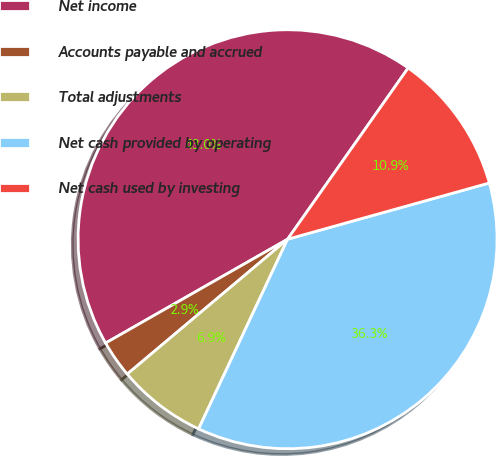Convert chart. <chart><loc_0><loc_0><loc_500><loc_500><pie_chart><fcel>Net income<fcel>Accounts payable and accrued<fcel>Total adjustments<fcel>Net cash provided by operating<fcel>Net cash used by investing<nl><fcel>43.02%<fcel>2.88%<fcel>6.89%<fcel>36.31%<fcel>10.91%<nl></chart> 